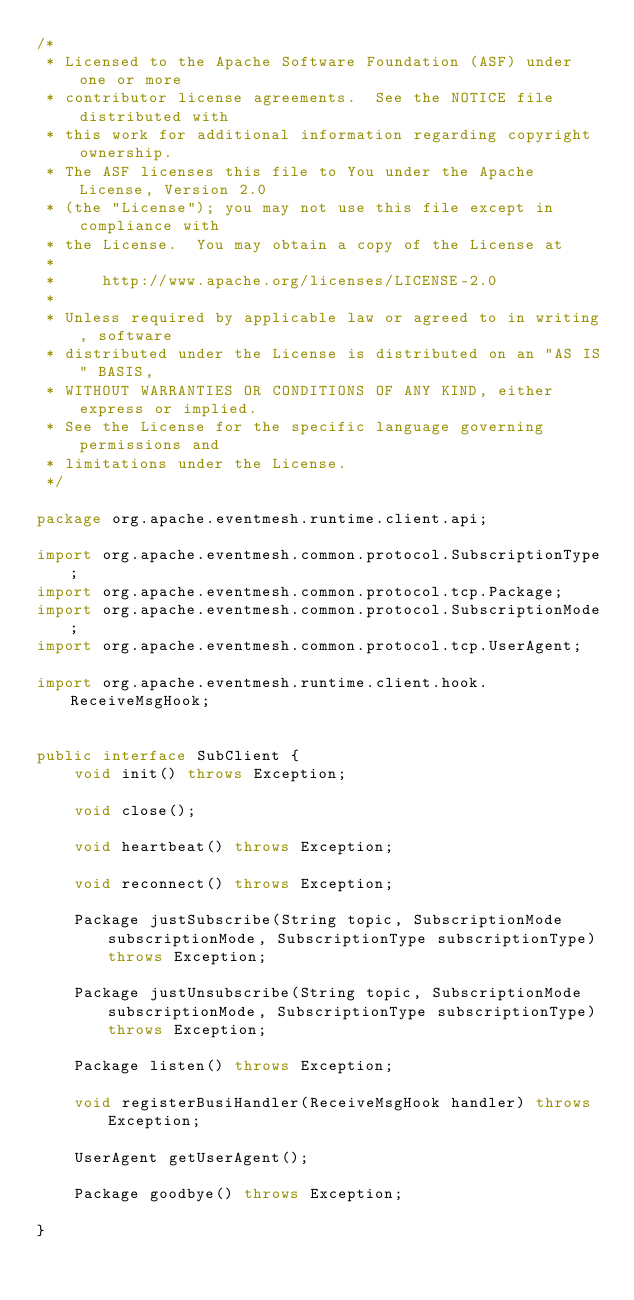Convert code to text. <code><loc_0><loc_0><loc_500><loc_500><_Java_>/*
 * Licensed to the Apache Software Foundation (ASF) under one or more
 * contributor license agreements.  See the NOTICE file distributed with
 * this work for additional information regarding copyright ownership.
 * The ASF licenses this file to You under the Apache License, Version 2.0
 * (the "License"); you may not use this file except in compliance with
 * the License.  You may obtain a copy of the License at
 *
 *     http://www.apache.org/licenses/LICENSE-2.0
 *
 * Unless required by applicable law or agreed to in writing, software
 * distributed under the License is distributed on an "AS IS" BASIS,
 * WITHOUT WARRANTIES OR CONDITIONS OF ANY KIND, either express or implied.
 * See the License for the specific language governing permissions and
 * limitations under the License.
 */

package org.apache.eventmesh.runtime.client.api;

import org.apache.eventmesh.common.protocol.SubscriptionType;
import org.apache.eventmesh.common.protocol.tcp.Package;
import org.apache.eventmesh.common.protocol.SubscriptionMode;
import org.apache.eventmesh.common.protocol.tcp.UserAgent;

import org.apache.eventmesh.runtime.client.hook.ReceiveMsgHook;


public interface SubClient {
    void init() throws Exception;

    void close();

    void heartbeat() throws Exception;

    void reconnect() throws Exception;

    Package justSubscribe(String topic, SubscriptionMode subscriptionMode, SubscriptionType subscriptionType) throws Exception;

    Package justUnsubscribe(String topic, SubscriptionMode subscriptionMode, SubscriptionType subscriptionType) throws Exception;

    Package listen() throws Exception;

    void registerBusiHandler(ReceiveMsgHook handler) throws Exception;

    UserAgent getUserAgent();

    Package goodbye() throws Exception;

}
</code> 